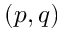Convert formula to latex. <formula><loc_0><loc_0><loc_500><loc_500>\left ( p , q \right )</formula> 